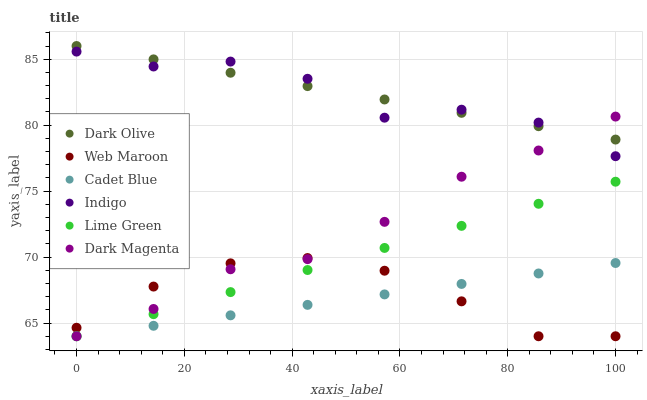Does Cadet Blue have the minimum area under the curve?
Answer yes or no. Yes. Does Dark Olive have the maximum area under the curve?
Answer yes or no. Yes. Does Indigo have the minimum area under the curve?
Answer yes or no. No. Does Indigo have the maximum area under the curve?
Answer yes or no. No. Is Cadet Blue the smoothest?
Answer yes or no. Yes. Is Indigo the roughest?
Answer yes or no. Yes. Is Dark Magenta the smoothest?
Answer yes or no. No. Is Dark Magenta the roughest?
Answer yes or no. No. Does Cadet Blue have the lowest value?
Answer yes or no. Yes. Does Indigo have the lowest value?
Answer yes or no. No. Does Dark Olive have the highest value?
Answer yes or no. Yes. Does Indigo have the highest value?
Answer yes or no. No. Is Web Maroon less than Dark Olive?
Answer yes or no. Yes. Is Indigo greater than Web Maroon?
Answer yes or no. Yes. Does Lime Green intersect Cadet Blue?
Answer yes or no. Yes. Is Lime Green less than Cadet Blue?
Answer yes or no. No. Is Lime Green greater than Cadet Blue?
Answer yes or no. No. Does Web Maroon intersect Dark Olive?
Answer yes or no. No. 